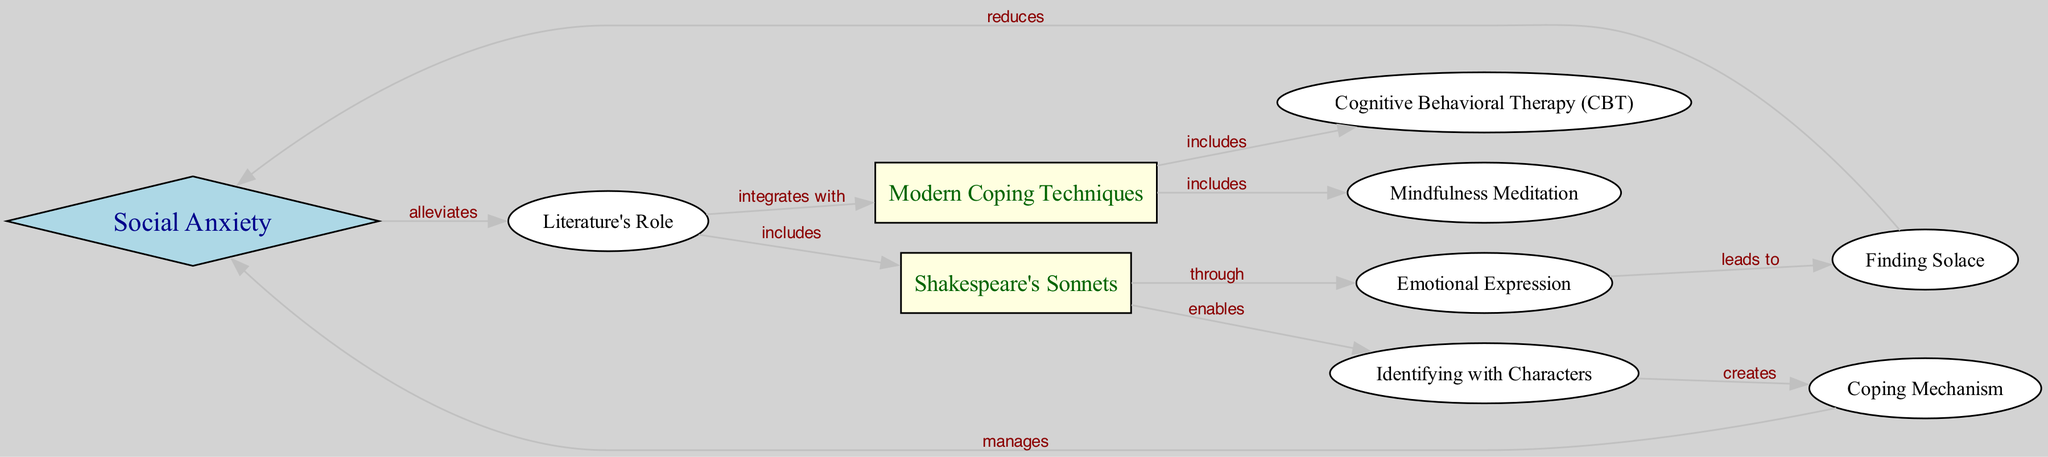What is the primary topic of the diagram? The central theme of the diagram is represented by the node labeled "Social Anxiety," which is the starting point for various connections in the mind map.
Answer: Social Anxiety How many nodes are in the diagram? By counting each entry in the nodes list, we find that there are a total of 10 distinct nodes, each representing different concepts related to the main topic.
Answer: 10 What role does literature play in relation to social anxiety? The edge connecting "Social Anxiety" and "Literature's Role" indicates that literature is said to alleviate social anxiety, showing its importance in this context.
Answer: alleviates Which two nodes are connected by the label "includes"? The term "includes" connects the node "Literature's Role" to two others: "Shakespeare's Sonnets" and "Modern Coping Techniques." This indicates that both of these elements are part of the greater role literature plays.
Answer: Shakespeare's Sonnets and Modern Coping Techniques How does Shakespeare's Sonnets lead to finding solace? The relationship outlined in the diagram shows that "Emotional Expression" arising from "Shakespeare's Sonnets" leads directly to "Finding Solace," indicating an emotional release that provides comfort.
Answer: leads to What modern coping technique is associated with Shakespeare's Sonnets? The edge from "Literature's Role" to "Modern Coping Techniques" suggests that Shakespeare's Sonnets integrate with modern techniques; specifically, "Cognitive Behavioral Therapy" and "Mindfulness Meditation" are enumerated under "Modern Coping Techniques" as methods that can be linked back to literature's influence.
Answer: Cognitive Behavioral Therapy and Mindfulness Meditation What is created from identifying with characters? The node "Identifying with Characters" generates a "Coping Mechanism", which indicates that connection to literary characters can result in strategies that help manage social anxiety.
Answer: Coping Mechanism How do modern coping techniques affect social anxiety? The edge drawn from "Finding Solace" connects back to "Social Anxiety", indicating that finding solace through literature or coping techniques actively works to reduce social anxiety symptoms.
Answer: reduces 